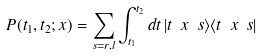Convert formula to latex. <formula><loc_0><loc_0><loc_500><loc_500>P ( t _ { 1 } , t _ { 2 } ; x ) = \sum _ { s = r , l } \int _ { t _ { 1 } } ^ { t _ { 2 } } d t \, | t \ x \ s \rangle \langle t \ x \ s |</formula> 